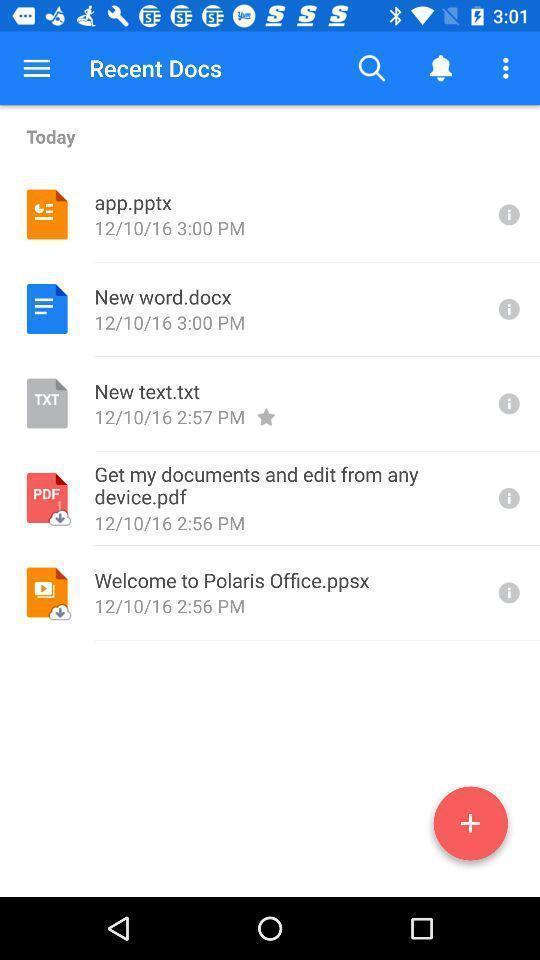Summarize the information in this screenshot. Recent page showing all the files. 